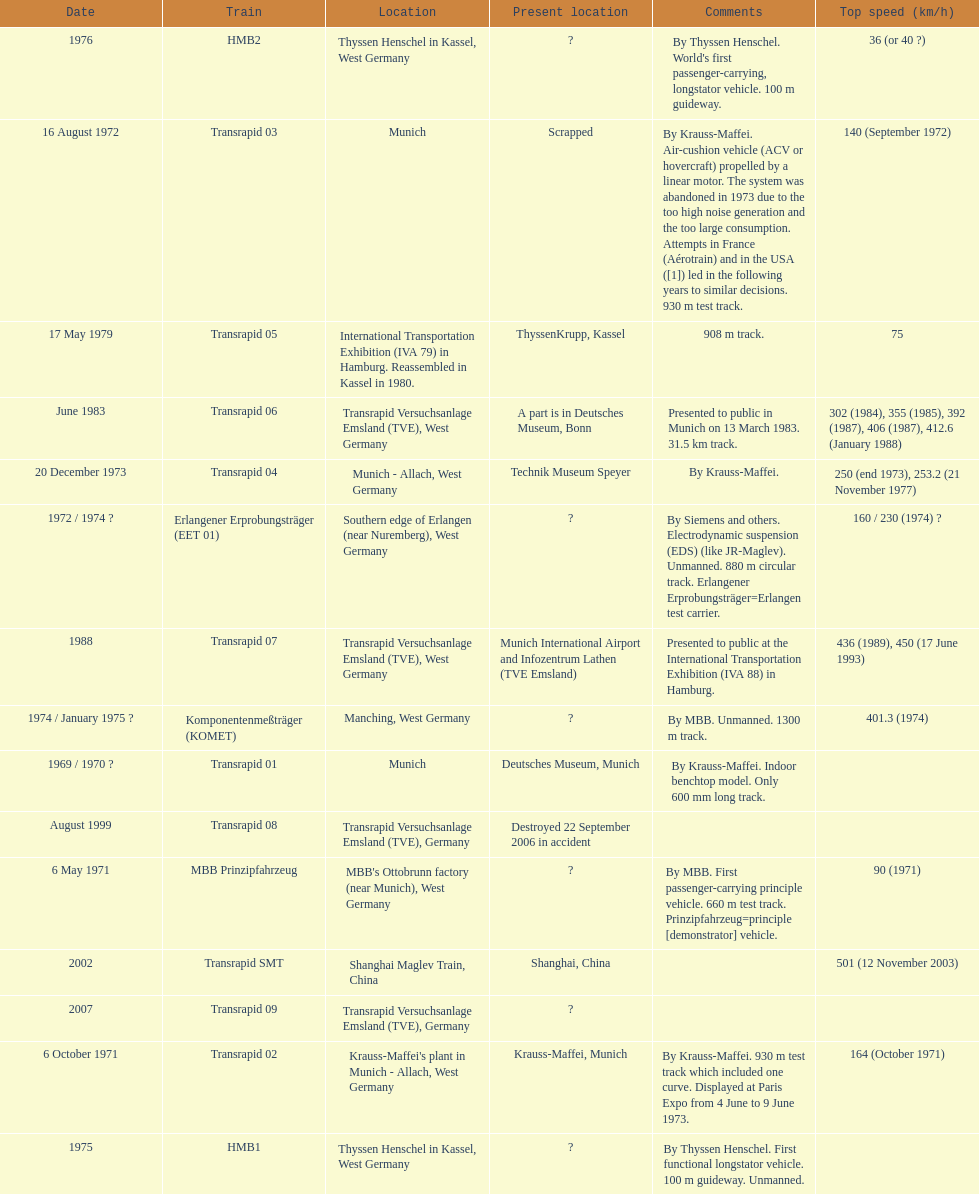What is the number of trains that were either scrapped or destroyed? 2. Could you parse the entire table as a dict? {'header': ['Date', 'Train', 'Location', 'Present location', 'Comments', 'Top speed (km/h)'], 'rows': [['1976', 'HMB2', 'Thyssen Henschel in Kassel, West Germany', '?', "By Thyssen Henschel. World's first passenger-carrying, longstator vehicle. 100 m guideway.", '36 (or 40\xa0?)'], ['16 August 1972', 'Transrapid 03', 'Munich', 'Scrapped', 'By Krauss-Maffei. Air-cushion vehicle (ACV or hovercraft) propelled by a linear motor. The system was abandoned in 1973 due to the too high noise generation and the too large consumption. Attempts in France (Aérotrain) and in the USA ([1]) led in the following years to similar decisions. 930 m test track.', '140 (September 1972)'], ['17 May 1979', 'Transrapid 05', 'International Transportation Exhibition (IVA 79) in Hamburg. Reassembled in Kassel in 1980.', 'ThyssenKrupp, Kassel', '908 m track.', '75'], ['June 1983', 'Transrapid 06', 'Transrapid Versuchsanlage Emsland (TVE), West Germany', 'A part is in Deutsches Museum, Bonn', 'Presented to public in Munich on 13 March 1983. 31.5\xa0km track.', '302 (1984), 355 (1985), 392 (1987), 406 (1987), 412.6 (January 1988)'], ['20 December 1973', 'Transrapid 04', 'Munich - Allach, West Germany', 'Technik Museum Speyer', 'By Krauss-Maffei.', '250 (end 1973), 253.2 (21 November 1977)'], ['1972 / 1974\xa0?', 'Erlangener Erprobungsträger (EET 01)', 'Southern edge of Erlangen (near Nuremberg), West Germany', '?', 'By Siemens and others. Electrodynamic suspension (EDS) (like JR-Maglev). Unmanned. 880 m circular track. Erlangener Erprobungsträger=Erlangen test carrier.', '160 / 230 (1974)\xa0?'], ['1988', 'Transrapid 07', 'Transrapid Versuchsanlage Emsland (TVE), West Germany', 'Munich International Airport and Infozentrum Lathen (TVE Emsland)', 'Presented to public at the International Transportation Exhibition (IVA 88) in Hamburg.', '436 (1989), 450 (17 June 1993)'], ['1974 / January 1975\xa0?', 'Komponentenmeßträger (KOMET)', 'Manching, West Germany', '?', 'By MBB. Unmanned. 1300 m track.', '401.3 (1974)'], ['1969 / 1970\xa0?', 'Transrapid 01', 'Munich', 'Deutsches Museum, Munich', 'By Krauss-Maffei. Indoor benchtop model. Only 600\xa0mm long track.', ''], ['August 1999', 'Transrapid 08', 'Transrapid Versuchsanlage Emsland (TVE), Germany', 'Destroyed 22 September 2006 in accident', '', ''], ['6 May 1971', 'MBB Prinzipfahrzeug', "MBB's Ottobrunn factory (near Munich), West Germany", '?', 'By MBB. First passenger-carrying principle vehicle. 660 m test track. Prinzipfahrzeug=principle [demonstrator] vehicle.', '90 (1971)'], ['2002', 'Transrapid SMT', 'Shanghai Maglev Train, China', 'Shanghai, China', '', '501 (12 November 2003)'], ['2007', 'Transrapid 09', 'Transrapid Versuchsanlage Emsland (TVE), Germany', '?', '', ''], ['6 October 1971', 'Transrapid 02', "Krauss-Maffei's plant in Munich - Allach, West Germany", 'Krauss-Maffei, Munich', 'By Krauss-Maffei. 930 m test track which included one curve. Displayed at Paris Expo from 4 June to 9 June 1973.', '164 (October 1971)'], ['1975', 'HMB1', 'Thyssen Henschel in Kassel, West Germany', '?', 'By Thyssen Henschel. First functional longstator vehicle. 100 m guideway. Unmanned.', '']]} 